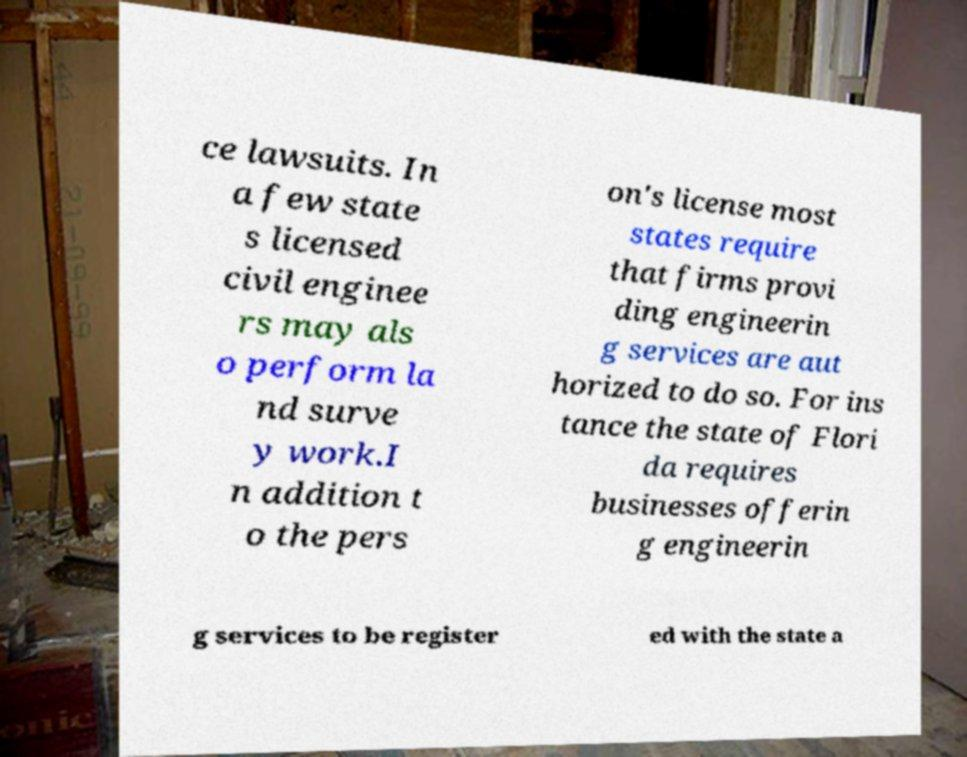Can you accurately transcribe the text from the provided image for me? ce lawsuits. In a few state s licensed civil enginee rs may als o perform la nd surve y work.I n addition t o the pers on's license most states require that firms provi ding engineerin g services are aut horized to do so. For ins tance the state of Flori da requires businesses offerin g engineerin g services to be register ed with the state a 